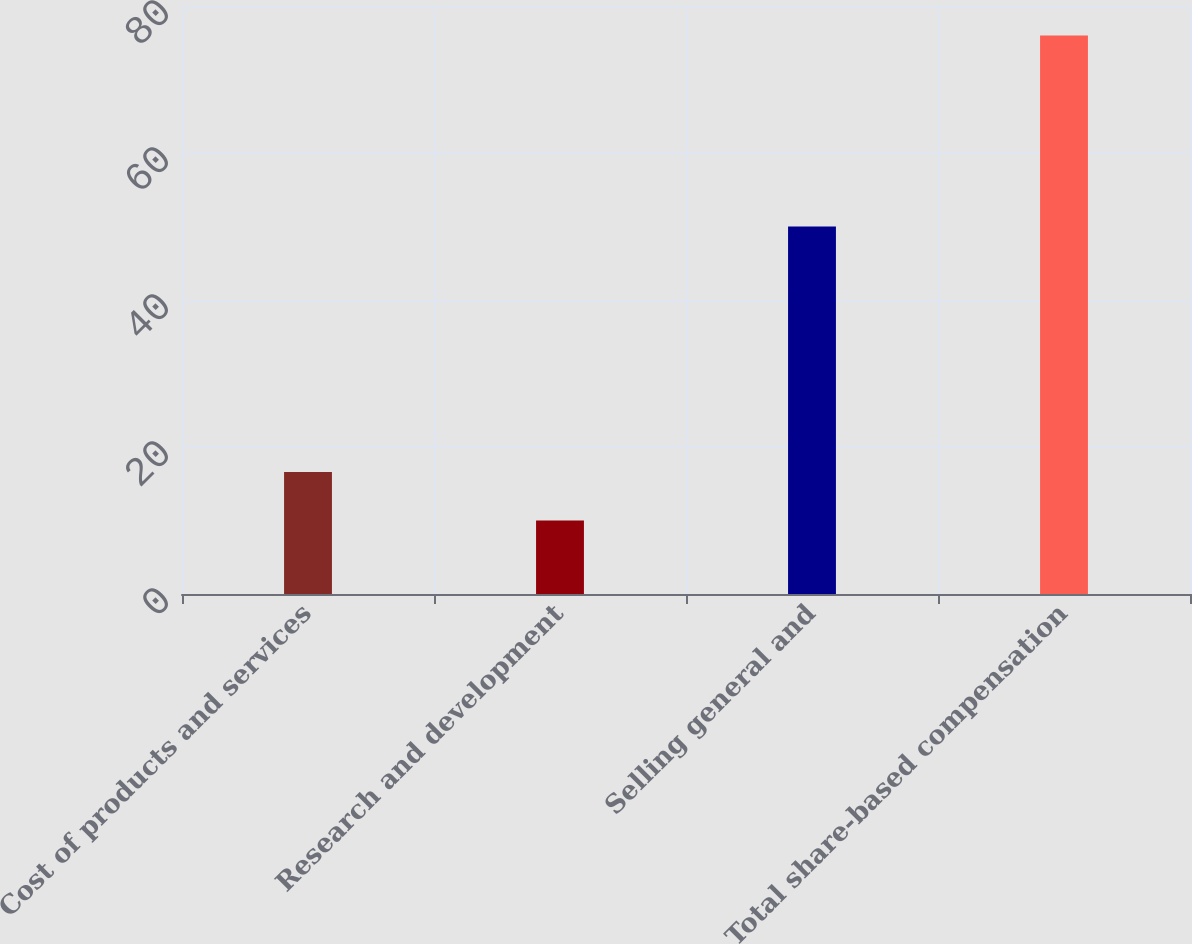<chart> <loc_0><loc_0><loc_500><loc_500><bar_chart><fcel>Cost of products and services<fcel>Research and development<fcel>Selling general and<fcel>Total share-based compensation<nl><fcel>16.6<fcel>10<fcel>50<fcel>76<nl></chart> 